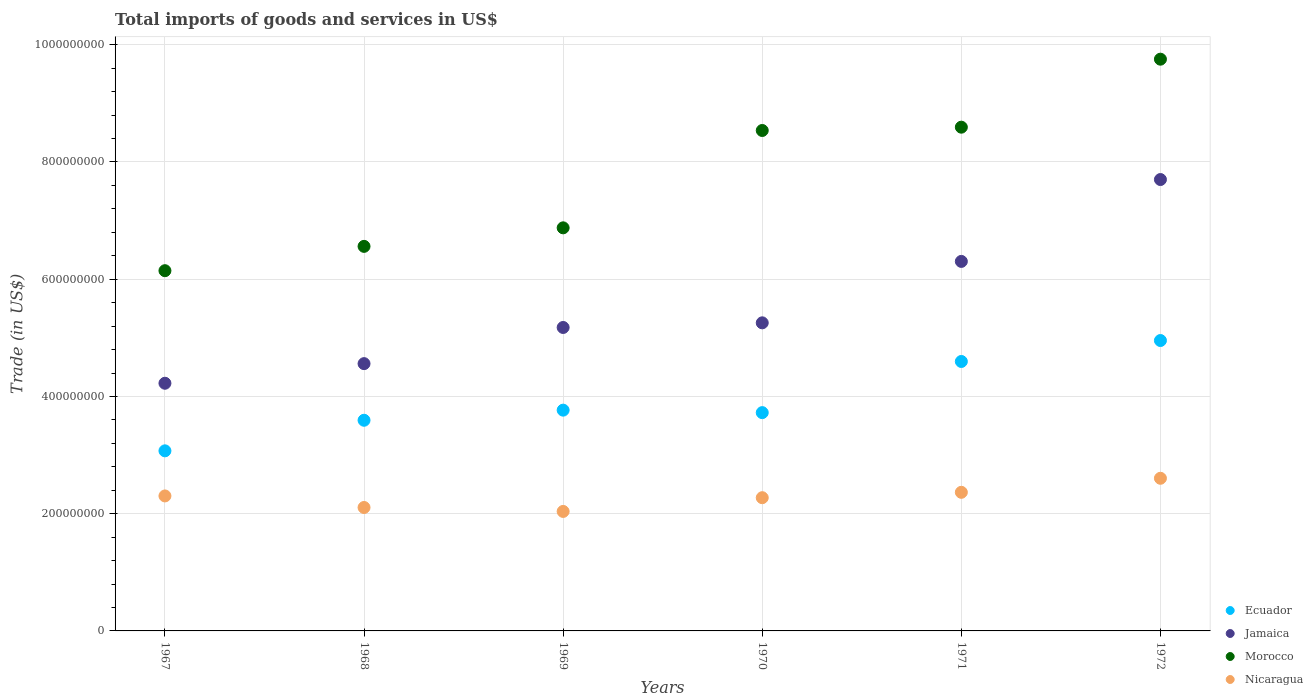What is the total imports of goods and services in Morocco in 1971?
Provide a succinct answer. 8.59e+08. Across all years, what is the maximum total imports of goods and services in Nicaragua?
Provide a short and direct response. 2.60e+08. Across all years, what is the minimum total imports of goods and services in Ecuador?
Offer a very short reply. 3.07e+08. In which year was the total imports of goods and services in Nicaragua minimum?
Your answer should be very brief. 1969. What is the total total imports of goods and services in Ecuador in the graph?
Offer a very short reply. 2.37e+09. What is the difference between the total imports of goods and services in Ecuador in 1969 and that in 1972?
Offer a terse response. -1.19e+08. What is the difference between the total imports of goods and services in Morocco in 1969 and the total imports of goods and services in Jamaica in 1967?
Offer a terse response. 2.65e+08. What is the average total imports of goods and services in Nicaragua per year?
Keep it short and to the point. 2.28e+08. In the year 1968, what is the difference between the total imports of goods and services in Jamaica and total imports of goods and services in Nicaragua?
Keep it short and to the point. 2.45e+08. What is the ratio of the total imports of goods and services in Morocco in 1969 to that in 1972?
Give a very brief answer. 0.71. Is the total imports of goods and services in Morocco in 1968 less than that in 1972?
Give a very brief answer. Yes. What is the difference between the highest and the second highest total imports of goods and services in Morocco?
Keep it short and to the point. 1.16e+08. What is the difference between the highest and the lowest total imports of goods and services in Jamaica?
Provide a succinct answer. 3.48e+08. Is it the case that in every year, the sum of the total imports of goods and services in Ecuador and total imports of goods and services in Jamaica  is greater than the total imports of goods and services in Morocco?
Keep it short and to the point. Yes. Does the total imports of goods and services in Ecuador monotonically increase over the years?
Ensure brevity in your answer.  No. Is the total imports of goods and services in Morocco strictly greater than the total imports of goods and services in Nicaragua over the years?
Ensure brevity in your answer.  Yes. Is the total imports of goods and services in Nicaragua strictly less than the total imports of goods and services in Jamaica over the years?
Offer a very short reply. Yes. How many years are there in the graph?
Offer a terse response. 6. What is the difference between two consecutive major ticks on the Y-axis?
Offer a very short reply. 2.00e+08. Are the values on the major ticks of Y-axis written in scientific E-notation?
Offer a terse response. No. Does the graph contain any zero values?
Your answer should be very brief. No. Does the graph contain grids?
Offer a very short reply. Yes. What is the title of the graph?
Offer a terse response. Total imports of goods and services in US$. Does "Papua New Guinea" appear as one of the legend labels in the graph?
Offer a terse response. No. What is the label or title of the X-axis?
Offer a terse response. Years. What is the label or title of the Y-axis?
Your answer should be very brief. Trade (in US$). What is the Trade (in US$) of Ecuador in 1967?
Offer a very short reply. 3.07e+08. What is the Trade (in US$) of Jamaica in 1967?
Keep it short and to the point. 4.23e+08. What is the Trade (in US$) in Morocco in 1967?
Give a very brief answer. 6.15e+08. What is the Trade (in US$) of Nicaragua in 1967?
Offer a terse response. 2.30e+08. What is the Trade (in US$) of Ecuador in 1968?
Ensure brevity in your answer.  3.59e+08. What is the Trade (in US$) in Jamaica in 1968?
Give a very brief answer. 4.56e+08. What is the Trade (in US$) in Morocco in 1968?
Your response must be concise. 6.56e+08. What is the Trade (in US$) in Nicaragua in 1968?
Make the answer very short. 2.11e+08. What is the Trade (in US$) of Ecuador in 1969?
Your answer should be compact. 3.77e+08. What is the Trade (in US$) in Jamaica in 1969?
Make the answer very short. 5.18e+08. What is the Trade (in US$) of Morocco in 1969?
Your answer should be compact. 6.88e+08. What is the Trade (in US$) of Nicaragua in 1969?
Your answer should be very brief. 2.04e+08. What is the Trade (in US$) in Ecuador in 1970?
Ensure brevity in your answer.  3.72e+08. What is the Trade (in US$) of Jamaica in 1970?
Your answer should be very brief. 5.26e+08. What is the Trade (in US$) in Morocco in 1970?
Ensure brevity in your answer.  8.54e+08. What is the Trade (in US$) in Nicaragua in 1970?
Offer a terse response. 2.27e+08. What is the Trade (in US$) in Ecuador in 1971?
Offer a terse response. 4.60e+08. What is the Trade (in US$) in Jamaica in 1971?
Provide a short and direct response. 6.30e+08. What is the Trade (in US$) of Morocco in 1971?
Your answer should be compact. 8.59e+08. What is the Trade (in US$) in Nicaragua in 1971?
Provide a short and direct response. 2.36e+08. What is the Trade (in US$) in Ecuador in 1972?
Your response must be concise. 4.95e+08. What is the Trade (in US$) of Jamaica in 1972?
Provide a short and direct response. 7.70e+08. What is the Trade (in US$) in Morocco in 1972?
Give a very brief answer. 9.75e+08. What is the Trade (in US$) of Nicaragua in 1972?
Keep it short and to the point. 2.60e+08. Across all years, what is the maximum Trade (in US$) of Ecuador?
Your answer should be compact. 4.95e+08. Across all years, what is the maximum Trade (in US$) of Jamaica?
Your answer should be very brief. 7.70e+08. Across all years, what is the maximum Trade (in US$) of Morocco?
Keep it short and to the point. 9.75e+08. Across all years, what is the maximum Trade (in US$) in Nicaragua?
Offer a terse response. 2.60e+08. Across all years, what is the minimum Trade (in US$) of Ecuador?
Offer a terse response. 3.07e+08. Across all years, what is the minimum Trade (in US$) in Jamaica?
Provide a succinct answer. 4.23e+08. Across all years, what is the minimum Trade (in US$) of Morocco?
Offer a very short reply. 6.15e+08. Across all years, what is the minimum Trade (in US$) of Nicaragua?
Ensure brevity in your answer.  2.04e+08. What is the total Trade (in US$) in Ecuador in the graph?
Offer a terse response. 2.37e+09. What is the total Trade (in US$) in Jamaica in the graph?
Your answer should be very brief. 3.32e+09. What is the total Trade (in US$) in Morocco in the graph?
Your answer should be very brief. 4.65e+09. What is the total Trade (in US$) in Nicaragua in the graph?
Your answer should be compact. 1.37e+09. What is the difference between the Trade (in US$) in Ecuador in 1967 and that in 1968?
Ensure brevity in your answer.  -5.22e+07. What is the difference between the Trade (in US$) in Jamaica in 1967 and that in 1968?
Your answer should be very brief. -3.35e+07. What is the difference between the Trade (in US$) of Morocco in 1967 and that in 1968?
Your response must be concise. -4.15e+07. What is the difference between the Trade (in US$) of Nicaragua in 1967 and that in 1968?
Offer a terse response. 1.97e+07. What is the difference between the Trade (in US$) of Ecuador in 1967 and that in 1969?
Your response must be concise. -6.94e+07. What is the difference between the Trade (in US$) of Jamaica in 1967 and that in 1969?
Offer a terse response. -9.51e+07. What is the difference between the Trade (in US$) of Morocco in 1967 and that in 1969?
Provide a short and direct response. -7.31e+07. What is the difference between the Trade (in US$) of Nicaragua in 1967 and that in 1969?
Your response must be concise. 2.64e+07. What is the difference between the Trade (in US$) in Ecuador in 1967 and that in 1970?
Your answer should be very brief. -6.52e+07. What is the difference between the Trade (in US$) of Jamaica in 1967 and that in 1970?
Offer a terse response. -1.03e+08. What is the difference between the Trade (in US$) in Morocco in 1967 and that in 1970?
Your response must be concise. -2.39e+08. What is the difference between the Trade (in US$) in Nicaragua in 1967 and that in 1970?
Provide a succinct answer. 3.01e+06. What is the difference between the Trade (in US$) in Ecuador in 1967 and that in 1971?
Provide a short and direct response. -1.52e+08. What is the difference between the Trade (in US$) of Jamaica in 1967 and that in 1971?
Keep it short and to the point. -2.08e+08. What is the difference between the Trade (in US$) of Morocco in 1967 and that in 1971?
Ensure brevity in your answer.  -2.45e+08. What is the difference between the Trade (in US$) in Nicaragua in 1967 and that in 1971?
Your answer should be compact. -6.18e+06. What is the difference between the Trade (in US$) of Ecuador in 1967 and that in 1972?
Your answer should be compact. -1.88e+08. What is the difference between the Trade (in US$) of Jamaica in 1967 and that in 1972?
Provide a succinct answer. -3.48e+08. What is the difference between the Trade (in US$) of Morocco in 1967 and that in 1972?
Your response must be concise. -3.61e+08. What is the difference between the Trade (in US$) of Nicaragua in 1967 and that in 1972?
Your response must be concise. -3.01e+07. What is the difference between the Trade (in US$) of Ecuador in 1968 and that in 1969?
Offer a very short reply. -1.73e+07. What is the difference between the Trade (in US$) in Jamaica in 1968 and that in 1969?
Your answer should be compact. -6.17e+07. What is the difference between the Trade (in US$) of Morocco in 1968 and that in 1969?
Offer a very short reply. -3.16e+07. What is the difference between the Trade (in US$) of Nicaragua in 1968 and that in 1969?
Ensure brevity in your answer.  6.72e+06. What is the difference between the Trade (in US$) in Ecuador in 1968 and that in 1970?
Give a very brief answer. -1.30e+07. What is the difference between the Trade (in US$) in Jamaica in 1968 and that in 1970?
Provide a succinct answer. -6.96e+07. What is the difference between the Trade (in US$) in Morocco in 1968 and that in 1970?
Your answer should be compact. -1.98e+08. What is the difference between the Trade (in US$) in Nicaragua in 1968 and that in 1970?
Give a very brief answer. -1.67e+07. What is the difference between the Trade (in US$) of Ecuador in 1968 and that in 1971?
Your response must be concise. -1.00e+08. What is the difference between the Trade (in US$) in Jamaica in 1968 and that in 1971?
Keep it short and to the point. -1.74e+08. What is the difference between the Trade (in US$) of Morocco in 1968 and that in 1971?
Keep it short and to the point. -2.03e+08. What is the difference between the Trade (in US$) of Nicaragua in 1968 and that in 1971?
Your answer should be compact. -2.59e+07. What is the difference between the Trade (in US$) of Ecuador in 1968 and that in 1972?
Your answer should be compact. -1.36e+08. What is the difference between the Trade (in US$) of Jamaica in 1968 and that in 1972?
Your response must be concise. -3.14e+08. What is the difference between the Trade (in US$) in Morocco in 1968 and that in 1972?
Provide a succinct answer. -3.19e+08. What is the difference between the Trade (in US$) in Nicaragua in 1968 and that in 1972?
Your answer should be compact. -4.99e+07. What is the difference between the Trade (in US$) in Ecuador in 1969 and that in 1970?
Your answer should be compact. 4.23e+06. What is the difference between the Trade (in US$) of Jamaica in 1969 and that in 1970?
Offer a terse response. -7.92e+06. What is the difference between the Trade (in US$) of Morocco in 1969 and that in 1970?
Your answer should be very brief. -1.66e+08. What is the difference between the Trade (in US$) in Nicaragua in 1969 and that in 1970?
Your answer should be compact. -2.34e+07. What is the difference between the Trade (in US$) in Ecuador in 1969 and that in 1971?
Provide a short and direct response. -8.30e+07. What is the difference between the Trade (in US$) in Jamaica in 1969 and that in 1971?
Give a very brief answer. -1.13e+08. What is the difference between the Trade (in US$) of Morocco in 1969 and that in 1971?
Offer a very short reply. -1.72e+08. What is the difference between the Trade (in US$) in Nicaragua in 1969 and that in 1971?
Give a very brief answer. -3.26e+07. What is the difference between the Trade (in US$) of Ecuador in 1969 and that in 1972?
Provide a succinct answer. -1.19e+08. What is the difference between the Trade (in US$) of Jamaica in 1969 and that in 1972?
Your answer should be very brief. -2.52e+08. What is the difference between the Trade (in US$) in Morocco in 1969 and that in 1972?
Your response must be concise. -2.88e+08. What is the difference between the Trade (in US$) of Nicaragua in 1969 and that in 1972?
Provide a short and direct response. -5.66e+07. What is the difference between the Trade (in US$) of Ecuador in 1970 and that in 1971?
Ensure brevity in your answer.  -8.73e+07. What is the difference between the Trade (in US$) in Jamaica in 1970 and that in 1971?
Your answer should be compact. -1.05e+08. What is the difference between the Trade (in US$) in Morocco in 1970 and that in 1971?
Offer a terse response. -5.64e+06. What is the difference between the Trade (in US$) in Nicaragua in 1970 and that in 1971?
Provide a succinct answer. -9.19e+06. What is the difference between the Trade (in US$) of Ecuador in 1970 and that in 1972?
Your response must be concise. -1.23e+08. What is the difference between the Trade (in US$) of Jamaica in 1970 and that in 1972?
Provide a short and direct response. -2.44e+08. What is the difference between the Trade (in US$) of Morocco in 1970 and that in 1972?
Your answer should be compact. -1.22e+08. What is the difference between the Trade (in US$) in Nicaragua in 1970 and that in 1972?
Provide a short and direct response. -3.31e+07. What is the difference between the Trade (in US$) in Ecuador in 1971 and that in 1972?
Your answer should be very brief. -3.57e+07. What is the difference between the Trade (in US$) in Jamaica in 1971 and that in 1972?
Offer a terse response. -1.40e+08. What is the difference between the Trade (in US$) of Morocco in 1971 and that in 1972?
Your response must be concise. -1.16e+08. What is the difference between the Trade (in US$) of Nicaragua in 1971 and that in 1972?
Offer a very short reply. -2.40e+07. What is the difference between the Trade (in US$) of Ecuador in 1967 and the Trade (in US$) of Jamaica in 1968?
Give a very brief answer. -1.49e+08. What is the difference between the Trade (in US$) in Ecuador in 1967 and the Trade (in US$) in Morocco in 1968?
Provide a succinct answer. -3.49e+08. What is the difference between the Trade (in US$) of Ecuador in 1967 and the Trade (in US$) of Nicaragua in 1968?
Provide a short and direct response. 9.67e+07. What is the difference between the Trade (in US$) of Jamaica in 1967 and the Trade (in US$) of Morocco in 1968?
Make the answer very short. -2.34e+08. What is the difference between the Trade (in US$) in Jamaica in 1967 and the Trade (in US$) in Nicaragua in 1968?
Your response must be concise. 2.12e+08. What is the difference between the Trade (in US$) of Morocco in 1967 and the Trade (in US$) of Nicaragua in 1968?
Give a very brief answer. 4.04e+08. What is the difference between the Trade (in US$) of Ecuador in 1967 and the Trade (in US$) of Jamaica in 1969?
Give a very brief answer. -2.10e+08. What is the difference between the Trade (in US$) in Ecuador in 1967 and the Trade (in US$) in Morocco in 1969?
Offer a very short reply. -3.80e+08. What is the difference between the Trade (in US$) in Ecuador in 1967 and the Trade (in US$) in Nicaragua in 1969?
Ensure brevity in your answer.  1.03e+08. What is the difference between the Trade (in US$) of Jamaica in 1967 and the Trade (in US$) of Morocco in 1969?
Offer a very short reply. -2.65e+08. What is the difference between the Trade (in US$) in Jamaica in 1967 and the Trade (in US$) in Nicaragua in 1969?
Provide a succinct answer. 2.19e+08. What is the difference between the Trade (in US$) of Morocco in 1967 and the Trade (in US$) of Nicaragua in 1969?
Provide a short and direct response. 4.11e+08. What is the difference between the Trade (in US$) in Ecuador in 1967 and the Trade (in US$) in Jamaica in 1970?
Make the answer very short. -2.18e+08. What is the difference between the Trade (in US$) of Ecuador in 1967 and the Trade (in US$) of Morocco in 1970?
Give a very brief answer. -5.47e+08. What is the difference between the Trade (in US$) in Ecuador in 1967 and the Trade (in US$) in Nicaragua in 1970?
Your answer should be very brief. 8.00e+07. What is the difference between the Trade (in US$) of Jamaica in 1967 and the Trade (in US$) of Morocco in 1970?
Keep it short and to the point. -4.31e+08. What is the difference between the Trade (in US$) of Jamaica in 1967 and the Trade (in US$) of Nicaragua in 1970?
Make the answer very short. 1.95e+08. What is the difference between the Trade (in US$) of Morocco in 1967 and the Trade (in US$) of Nicaragua in 1970?
Provide a short and direct response. 3.87e+08. What is the difference between the Trade (in US$) in Ecuador in 1967 and the Trade (in US$) in Jamaica in 1971?
Provide a succinct answer. -3.23e+08. What is the difference between the Trade (in US$) in Ecuador in 1967 and the Trade (in US$) in Morocco in 1971?
Your answer should be compact. -5.52e+08. What is the difference between the Trade (in US$) of Ecuador in 1967 and the Trade (in US$) of Nicaragua in 1971?
Your answer should be very brief. 7.08e+07. What is the difference between the Trade (in US$) in Jamaica in 1967 and the Trade (in US$) in Morocco in 1971?
Provide a succinct answer. -4.37e+08. What is the difference between the Trade (in US$) of Jamaica in 1967 and the Trade (in US$) of Nicaragua in 1971?
Your answer should be very brief. 1.86e+08. What is the difference between the Trade (in US$) in Morocco in 1967 and the Trade (in US$) in Nicaragua in 1971?
Ensure brevity in your answer.  3.78e+08. What is the difference between the Trade (in US$) of Ecuador in 1967 and the Trade (in US$) of Jamaica in 1972?
Make the answer very short. -4.63e+08. What is the difference between the Trade (in US$) of Ecuador in 1967 and the Trade (in US$) of Morocco in 1972?
Offer a terse response. -6.68e+08. What is the difference between the Trade (in US$) of Ecuador in 1967 and the Trade (in US$) of Nicaragua in 1972?
Ensure brevity in your answer.  4.68e+07. What is the difference between the Trade (in US$) in Jamaica in 1967 and the Trade (in US$) in Morocco in 1972?
Keep it short and to the point. -5.53e+08. What is the difference between the Trade (in US$) of Jamaica in 1967 and the Trade (in US$) of Nicaragua in 1972?
Your response must be concise. 1.62e+08. What is the difference between the Trade (in US$) of Morocco in 1967 and the Trade (in US$) of Nicaragua in 1972?
Give a very brief answer. 3.54e+08. What is the difference between the Trade (in US$) in Ecuador in 1968 and the Trade (in US$) in Jamaica in 1969?
Provide a succinct answer. -1.58e+08. What is the difference between the Trade (in US$) in Ecuador in 1968 and the Trade (in US$) in Morocco in 1969?
Offer a terse response. -3.28e+08. What is the difference between the Trade (in US$) of Ecuador in 1968 and the Trade (in US$) of Nicaragua in 1969?
Your answer should be compact. 1.56e+08. What is the difference between the Trade (in US$) in Jamaica in 1968 and the Trade (in US$) in Morocco in 1969?
Your response must be concise. -2.32e+08. What is the difference between the Trade (in US$) in Jamaica in 1968 and the Trade (in US$) in Nicaragua in 1969?
Your answer should be very brief. 2.52e+08. What is the difference between the Trade (in US$) in Morocco in 1968 and the Trade (in US$) in Nicaragua in 1969?
Keep it short and to the point. 4.52e+08. What is the difference between the Trade (in US$) of Ecuador in 1968 and the Trade (in US$) of Jamaica in 1970?
Give a very brief answer. -1.66e+08. What is the difference between the Trade (in US$) of Ecuador in 1968 and the Trade (in US$) of Morocco in 1970?
Your response must be concise. -4.94e+08. What is the difference between the Trade (in US$) of Ecuador in 1968 and the Trade (in US$) of Nicaragua in 1970?
Give a very brief answer. 1.32e+08. What is the difference between the Trade (in US$) in Jamaica in 1968 and the Trade (in US$) in Morocco in 1970?
Provide a succinct answer. -3.98e+08. What is the difference between the Trade (in US$) in Jamaica in 1968 and the Trade (in US$) in Nicaragua in 1970?
Your response must be concise. 2.29e+08. What is the difference between the Trade (in US$) of Morocco in 1968 and the Trade (in US$) of Nicaragua in 1970?
Ensure brevity in your answer.  4.29e+08. What is the difference between the Trade (in US$) of Ecuador in 1968 and the Trade (in US$) of Jamaica in 1971?
Provide a succinct answer. -2.71e+08. What is the difference between the Trade (in US$) in Ecuador in 1968 and the Trade (in US$) in Morocco in 1971?
Provide a short and direct response. -5.00e+08. What is the difference between the Trade (in US$) in Ecuador in 1968 and the Trade (in US$) in Nicaragua in 1971?
Offer a terse response. 1.23e+08. What is the difference between the Trade (in US$) in Jamaica in 1968 and the Trade (in US$) in Morocco in 1971?
Ensure brevity in your answer.  -4.03e+08. What is the difference between the Trade (in US$) in Jamaica in 1968 and the Trade (in US$) in Nicaragua in 1971?
Give a very brief answer. 2.20e+08. What is the difference between the Trade (in US$) in Morocco in 1968 and the Trade (in US$) in Nicaragua in 1971?
Your answer should be very brief. 4.20e+08. What is the difference between the Trade (in US$) of Ecuador in 1968 and the Trade (in US$) of Jamaica in 1972?
Your answer should be compact. -4.11e+08. What is the difference between the Trade (in US$) of Ecuador in 1968 and the Trade (in US$) of Morocco in 1972?
Give a very brief answer. -6.16e+08. What is the difference between the Trade (in US$) of Ecuador in 1968 and the Trade (in US$) of Nicaragua in 1972?
Make the answer very short. 9.90e+07. What is the difference between the Trade (in US$) of Jamaica in 1968 and the Trade (in US$) of Morocco in 1972?
Make the answer very short. -5.19e+08. What is the difference between the Trade (in US$) in Jamaica in 1968 and the Trade (in US$) in Nicaragua in 1972?
Offer a very short reply. 1.96e+08. What is the difference between the Trade (in US$) in Morocco in 1968 and the Trade (in US$) in Nicaragua in 1972?
Ensure brevity in your answer.  3.96e+08. What is the difference between the Trade (in US$) in Ecuador in 1969 and the Trade (in US$) in Jamaica in 1970?
Ensure brevity in your answer.  -1.49e+08. What is the difference between the Trade (in US$) in Ecuador in 1969 and the Trade (in US$) in Morocco in 1970?
Provide a succinct answer. -4.77e+08. What is the difference between the Trade (in US$) in Ecuador in 1969 and the Trade (in US$) in Nicaragua in 1970?
Keep it short and to the point. 1.49e+08. What is the difference between the Trade (in US$) in Jamaica in 1969 and the Trade (in US$) in Morocco in 1970?
Offer a very short reply. -3.36e+08. What is the difference between the Trade (in US$) of Jamaica in 1969 and the Trade (in US$) of Nicaragua in 1970?
Offer a terse response. 2.90e+08. What is the difference between the Trade (in US$) in Morocco in 1969 and the Trade (in US$) in Nicaragua in 1970?
Keep it short and to the point. 4.60e+08. What is the difference between the Trade (in US$) of Ecuador in 1969 and the Trade (in US$) of Jamaica in 1971?
Your answer should be very brief. -2.54e+08. What is the difference between the Trade (in US$) of Ecuador in 1969 and the Trade (in US$) of Morocco in 1971?
Give a very brief answer. -4.83e+08. What is the difference between the Trade (in US$) of Ecuador in 1969 and the Trade (in US$) of Nicaragua in 1971?
Give a very brief answer. 1.40e+08. What is the difference between the Trade (in US$) in Jamaica in 1969 and the Trade (in US$) in Morocco in 1971?
Your answer should be compact. -3.42e+08. What is the difference between the Trade (in US$) in Jamaica in 1969 and the Trade (in US$) in Nicaragua in 1971?
Make the answer very short. 2.81e+08. What is the difference between the Trade (in US$) of Morocco in 1969 and the Trade (in US$) of Nicaragua in 1971?
Your answer should be very brief. 4.51e+08. What is the difference between the Trade (in US$) in Ecuador in 1969 and the Trade (in US$) in Jamaica in 1972?
Provide a succinct answer. -3.93e+08. What is the difference between the Trade (in US$) in Ecuador in 1969 and the Trade (in US$) in Morocco in 1972?
Offer a very short reply. -5.99e+08. What is the difference between the Trade (in US$) in Ecuador in 1969 and the Trade (in US$) in Nicaragua in 1972?
Offer a very short reply. 1.16e+08. What is the difference between the Trade (in US$) in Jamaica in 1969 and the Trade (in US$) in Morocco in 1972?
Ensure brevity in your answer.  -4.58e+08. What is the difference between the Trade (in US$) in Jamaica in 1969 and the Trade (in US$) in Nicaragua in 1972?
Offer a terse response. 2.57e+08. What is the difference between the Trade (in US$) of Morocco in 1969 and the Trade (in US$) of Nicaragua in 1972?
Your answer should be very brief. 4.27e+08. What is the difference between the Trade (in US$) of Ecuador in 1970 and the Trade (in US$) of Jamaica in 1971?
Your answer should be very brief. -2.58e+08. What is the difference between the Trade (in US$) of Ecuador in 1970 and the Trade (in US$) of Morocco in 1971?
Ensure brevity in your answer.  -4.87e+08. What is the difference between the Trade (in US$) of Ecuador in 1970 and the Trade (in US$) of Nicaragua in 1971?
Offer a terse response. 1.36e+08. What is the difference between the Trade (in US$) in Jamaica in 1970 and the Trade (in US$) in Morocco in 1971?
Ensure brevity in your answer.  -3.34e+08. What is the difference between the Trade (in US$) in Jamaica in 1970 and the Trade (in US$) in Nicaragua in 1971?
Keep it short and to the point. 2.89e+08. What is the difference between the Trade (in US$) of Morocco in 1970 and the Trade (in US$) of Nicaragua in 1971?
Offer a terse response. 6.17e+08. What is the difference between the Trade (in US$) in Ecuador in 1970 and the Trade (in US$) in Jamaica in 1972?
Keep it short and to the point. -3.98e+08. What is the difference between the Trade (in US$) in Ecuador in 1970 and the Trade (in US$) in Morocco in 1972?
Your answer should be very brief. -6.03e+08. What is the difference between the Trade (in US$) of Ecuador in 1970 and the Trade (in US$) of Nicaragua in 1972?
Provide a short and direct response. 1.12e+08. What is the difference between the Trade (in US$) of Jamaica in 1970 and the Trade (in US$) of Morocco in 1972?
Keep it short and to the point. -4.50e+08. What is the difference between the Trade (in US$) in Jamaica in 1970 and the Trade (in US$) in Nicaragua in 1972?
Offer a terse response. 2.65e+08. What is the difference between the Trade (in US$) of Morocco in 1970 and the Trade (in US$) of Nicaragua in 1972?
Keep it short and to the point. 5.93e+08. What is the difference between the Trade (in US$) in Ecuador in 1971 and the Trade (in US$) in Jamaica in 1972?
Provide a short and direct response. -3.10e+08. What is the difference between the Trade (in US$) in Ecuador in 1971 and the Trade (in US$) in Morocco in 1972?
Provide a succinct answer. -5.16e+08. What is the difference between the Trade (in US$) of Ecuador in 1971 and the Trade (in US$) of Nicaragua in 1972?
Provide a succinct answer. 1.99e+08. What is the difference between the Trade (in US$) of Jamaica in 1971 and the Trade (in US$) of Morocco in 1972?
Your response must be concise. -3.45e+08. What is the difference between the Trade (in US$) in Jamaica in 1971 and the Trade (in US$) in Nicaragua in 1972?
Give a very brief answer. 3.70e+08. What is the difference between the Trade (in US$) of Morocco in 1971 and the Trade (in US$) of Nicaragua in 1972?
Your answer should be compact. 5.99e+08. What is the average Trade (in US$) of Ecuador per year?
Provide a short and direct response. 3.95e+08. What is the average Trade (in US$) of Jamaica per year?
Offer a terse response. 5.54e+08. What is the average Trade (in US$) in Morocco per year?
Provide a succinct answer. 7.74e+08. What is the average Trade (in US$) of Nicaragua per year?
Make the answer very short. 2.28e+08. In the year 1967, what is the difference between the Trade (in US$) in Ecuador and Trade (in US$) in Jamaica?
Provide a succinct answer. -1.15e+08. In the year 1967, what is the difference between the Trade (in US$) in Ecuador and Trade (in US$) in Morocco?
Give a very brief answer. -3.07e+08. In the year 1967, what is the difference between the Trade (in US$) of Ecuador and Trade (in US$) of Nicaragua?
Provide a succinct answer. 7.69e+07. In the year 1967, what is the difference between the Trade (in US$) in Jamaica and Trade (in US$) in Morocco?
Offer a terse response. -1.92e+08. In the year 1967, what is the difference between the Trade (in US$) in Jamaica and Trade (in US$) in Nicaragua?
Your response must be concise. 1.92e+08. In the year 1967, what is the difference between the Trade (in US$) of Morocco and Trade (in US$) of Nicaragua?
Offer a terse response. 3.84e+08. In the year 1968, what is the difference between the Trade (in US$) in Ecuador and Trade (in US$) in Jamaica?
Offer a very short reply. -9.66e+07. In the year 1968, what is the difference between the Trade (in US$) in Ecuador and Trade (in US$) in Morocco?
Your answer should be very brief. -2.97e+08. In the year 1968, what is the difference between the Trade (in US$) of Ecuador and Trade (in US$) of Nicaragua?
Give a very brief answer. 1.49e+08. In the year 1968, what is the difference between the Trade (in US$) in Jamaica and Trade (in US$) in Morocco?
Your answer should be compact. -2.00e+08. In the year 1968, what is the difference between the Trade (in US$) in Jamaica and Trade (in US$) in Nicaragua?
Provide a short and direct response. 2.45e+08. In the year 1968, what is the difference between the Trade (in US$) in Morocco and Trade (in US$) in Nicaragua?
Give a very brief answer. 4.45e+08. In the year 1969, what is the difference between the Trade (in US$) in Ecuador and Trade (in US$) in Jamaica?
Your answer should be compact. -1.41e+08. In the year 1969, what is the difference between the Trade (in US$) of Ecuador and Trade (in US$) of Morocco?
Your answer should be compact. -3.11e+08. In the year 1969, what is the difference between the Trade (in US$) of Ecuador and Trade (in US$) of Nicaragua?
Offer a very short reply. 1.73e+08. In the year 1969, what is the difference between the Trade (in US$) in Jamaica and Trade (in US$) in Morocco?
Make the answer very short. -1.70e+08. In the year 1969, what is the difference between the Trade (in US$) in Jamaica and Trade (in US$) in Nicaragua?
Make the answer very short. 3.14e+08. In the year 1969, what is the difference between the Trade (in US$) in Morocco and Trade (in US$) in Nicaragua?
Ensure brevity in your answer.  4.84e+08. In the year 1970, what is the difference between the Trade (in US$) in Ecuador and Trade (in US$) in Jamaica?
Your answer should be compact. -1.53e+08. In the year 1970, what is the difference between the Trade (in US$) in Ecuador and Trade (in US$) in Morocco?
Make the answer very short. -4.81e+08. In the year 1970, what is the difference between the Trade (in US$) of Ecuador and Trade (in US$) of Nicaragua?
Your response must be concise. 1.45e+08. In the year 1970, what is the difference between the Trade (in US$) in Jamaica and Trade (in US$) in Morocco?
Make the answer very short. -3.28e+08. In the year 1970, what is the difference between the Trade (in US$) in Jamaica and Trade (in US$) in Nicaragua?
Offer a very short reply. 2.98e+08. In the year 1970, what is the difference between the Trade (in US$) of Morocco and Trade (in US$) of Nicaragua?
Give a very brief answer. 6.26e+08. In the year 1971, what is the difference between the Trade (in US$) of Ecuador and Trade (in US$) of Jamaica?
Your response must be concise. -1.71e+08. In the year 1971, what is the difference between the Trade (in US$) in Ecuador and Trade (in US$) in Morocco?
Your response must be concise. -4.00e+08. In the year 1971, what is the difference between the Trade (in US$) of Ecuador and Trade (in US$) of Nicaragua?
Give a very brief answer. 2.23e+08. In the year 1971, what is the difference between the Trade (in US$) in Jamaica and Trade (in US$) in Morocco?
Keep it short and to the point. -2.29e+08. In the year 1971, what is the difference between the Trade (in US$) in Jamaica and Trade (in US$) in Nicaragua?
Provide a short and direct response. 3.94e+08. In the year 1971, what is the difference between the Trade (in US$) in Morocco and Trade (in US$) in Nicaragua?
Provide a short and direct response. 6.23e+08. In the year 1972, what is the difference between the Trade (in US$) of Ecuador and Trade (in US$) of Jamaica?
Your response must be concise. -2.75e+08. In the year 1972, what is the difference between the Trade (in US$) of Ecuador and Trade (in US$) of Morocco?
Your answer should be compact. -4.80e+08. In the year 1972, what is the difference between the Trade (in US$) of Ecuador and Trade (in US$) of Nicaragua?
Offer a very short reply. 2.35e+08. In the year 1972, what is the difference between the Trade (in US$) of Jamaica and Trade (in US$) of Morocco?
Keep it short and to the point. -2.05e+08. In the year 1972, what is the difference between the Trade (in US$) of Jamaica and Trade (in US$) of Nicaragua?
Your answer should be very brief. 5.10e+08. In the year 1972, what is the difference between the Trade (in US$) in Morocco and Trade (in US$) in Nicaragua?
Your response must be concise. 7.15e+08. What is the ratio of the Trade (in US$) of Ecuador in 1967 to that in 1968?
Keep it short and to the point. 0.85. What is the ratio of the Trade (in US$) in Jamaica in 1967 to that in 1968?
Provide a short and direct response. 0.93. What is the ratio of the Trade (in US$) of Morocco in 1967 to that in 1968?
Your response must be concise. 0.94. What is the ratio of the Trade (in US$) of Nicaragua in 1967 to that in 1968?
Your answer should be compact. 1.09. What is the ratio of the Trade (in US$) in Ecuador in 1967 to that in 1969?
Offer a terse response. 0.82. What is the ratio of the Trade (in US$) of Jamaica in 1967 to that in 1969?
Offer a very short reply. 0.82. What is the ratio of the Trade (in US$) of Morocco in 1967 to that in 1969?
Your response must be concise. 0.89. What is the ratio of the Trade (in US$) in Nicaragua in 1967 to that in 1969?
Your response must be concise. 1.13. What is the ratio of the Trade (in US$) of Ecuador in 1967 to that in 1970?
Your answer should be very brief. 0.82. What is the ratio of the Trade (in US$) in Jamaica in 1967 to that in 1970?
Give a very brief answer. 0.8. What is the ratio of the Trade (in US$) of Morocco in 1967 to that in 1970?
Keep it short and to the point. 0.72. What is the ratio of the Trade (in US$) of Nicaragua in 1967 to that in 1970?
Keep it short and to the point. 1.01. What is the ratio of the Trade (in US$) in Ecuador in 1967 to that in 1971?
Your answer should be very brief. 0.67. What is the ratio of the Trade (in US$) of Jamaica in 1967 to that in 1971?
Provide a short and direct response. 0.67. What is the ratio of the Trade (in US$) in Morocco in 1967 to that in 1971?
Your response must be concise. 0.72. What is the ratio of the Trade (in US$) in Nicaragua in 1967 to that in 1971?
Your answer should be compact. 0.97. What is the ratio of the Trade (in US$) in Ecuador in 1967 to that in 1972?
Your response must be concise. 0.62. What is the ratio of the Trade (in US$) of Jamaica in 1967 to that in 1972?
Your response must be concise. 0.55. What is the ratio of the Trade (in US$) of Morocco in 1967 to that in 1972?
Give a very brief answer. 0.63. What is the ratio of the Trade (in US$) in Nicaragua in 1967 to that in 1972?
Your response must be concise. 0.88. What is the ratio of the Trade (in US$) of Ecuador in 1968 to that in 1969?
Keep it short and to the point. 0.95. What is the ratio of the Trade (in US$) in Jamaica in 1968 to that in 1969?
Provide a succinct answer. 0.88. What is the ratio of the Trade (in US$) of Morocco in 1968 to that in 1969?
Your response must be concise. 0.95. What is the ratio of the Trade (in US$) in Nicaragua in 1968 to that in 1969?
Keep it short and to the point. 1.03. What is the ratio of the Trade (in US$) of Ecuador in 1968 to that in 1970?
Keep it short and to the point. 0.96. What is the ratio of the Trade (in US$) of Jamaica in 1968 to that in 1970?
Provide a succinct answer. 0.87. What is the ratio of the Trade (in US$) in Morocco in 1968 to that in 1970?
Keep it short and to the point. 0.77. What is the ratio of the Trade (in US$) in Nicaragua in 1968 to that in 1970?
Keep it short and to the point. 0.93. What is the ratio of the Trade (in US$) of Ecuador in 1968 to that in 1971?
Keep it short and to the point. 0.78. What is the ratio of the Trade (in US$) of Jamaica in 1968 to that in 1971?
Give a very brief answer. 0.72. What is the ratio of the Trade (in US$) in Morocco in 1968 to that in 1971?
Offer a very short reply. 0.76. What is the ratio of the Trade (in US$) of Nicaragua in 1968 to that in 1971?
Your answer should be very brief. 0.89. What is the ratio of the Trade (in US$) in Ecuador in 1968 to that in 1972?
Make the answer very short. 0.73. What is the ratio of the Trade (in US$) in Jamaica in 1968 to that in 1972?
Give a very brief answer. 0.59. What is the ratio of the Trade (in US$) of Morocco in 1968 to that in 1972?
Your response must be concise. 0.67. What is the ratio of the Trade (in US$) of Nicaragua in 1968 to that in 1972?
Ensure brevity in your answer.  0.81. What is the ratio of the Trade (in US$) of Ecuador in 1969 to that in 1970?
Provide a succinct answer. 1.01. What is the ratio of the Trade (in US$) of Jamaica in 1969 to that in 1970?
Provide a succinct answer. 0.98. What is the ratio of the Trade (in US$) of Morocco in 1969 to that in 1970?
Provide a succinct answer. 0.81. What is the ratio of the Trade (in US$) of Nicaragua in 1969 to that in 1970?
Your response must be concise. 0.9. What is the ratio of the Trade (in US$) of Ecuador in 1969 to that in 1971?
Provide a succinct answer. 0.82. What is the ratio of the Trade (in US$) in Jamaica in 1969 to that in 1971?
Give a very brief answer. 0.82. What is the ratio of the Trade (in US$) of Morocco in 1969 to that in 1971?
Provide a succinct answer. 0.8. What is the ratio of the Trade (in US$) in Nicaragua in 1969 to that in 1971?
Ensure brevity in your answer.  0.86. What is the ratio of the Trade (in US$) of Ecuador in 1969 to that in 1972?
Your answer should be compact. 0.76. What is the ratio of the Trade (in US$) of Jamaica in 1969 to that in 1972?
Your answer should be compact. 0.67. What is the ratio of the Trade (in US$) in Morocco in 1969 to that in 1972?
Provide a succinct answer. 0.7. What is the ratio of the Trade (in US$) of Nicaragua in 1969 to that in 1972?
Keep it short and to the point. 0.78. What is the ratio of the Trade (in US$) of Ecuador in 1970 to that in 1971?
Offer a very short reply. 0.81. What is the ratio of the Trade (in US$) of Jamaica in 1970 to that in 1971?
Offer a very short reply. 0.83. What is the ratio of the Trade (in US$) in Morocco in 1970 to that in 1971?
Give a very brief answer. 0.99. What is the ratio of the Trade (in US$) in Nicaragua in 1970 to that in 1971?
Provide a succinct answer. 0.96. What is the ratio of the Trade (in US$) in Ecuador in 1970 to that in 1972?
Keep it short and to the point. 0.75. What is the ratio of the Trade (in US$) of Jamaica in 1970 to that in 1972?
Provide a succinct answer. 0.68. What is the ratio of the Trade (in US$) of Morocco in 1970 to that in 1972?
Provide a short and direct response. 0.88. What is the ratio of the Trade (in US$) in Nicaragua in 1970 to that in 1972?
Offer a terse response. 0.87. What is the ratio of the Trade (in US$) in Ecuador in 1971 to that in 1972?
Give a very brief answer. 0.93. What is the ratio of the Trade (in US$) in Jamaica in 1971 to that in 1972?
Give a very brief answer. 0.82. What is the ratio of the Trade (in US$) in Morocco in 1971 to that in 1972?
Your answer should be very brief. 0.88. What is the ratio of the Trade (in US$) in Nicaragua in 1971 to that in 1972?
Keep it short and to the point. 0.91. What is the difference between the highest and the second highest Trade (in US$) of Ecuador?
Keep it short and to the point. 3.57e+07. What is the difference between the highest and the second highest Trade (in US$) of Jamaica?
Your answer should be compact. 1.40e+08. What is the difference between the highest and the second highest Trade (in US$) in Morocco?
Your answer should be compact. 1.16e+08. What is the difference between the highest and the second highest Trade (in US$) in Nicaragua?
Make the answer very short. 2.40e+07. What is the difference between the highest and the lowest Trade (in US$) in Ecuador?
Offer a very short reply. 1.88e+08. What is the difference between the highest and the lowest Trade (in US$) in Jamaica?
Keep it short and to the point. 3.48e+08. What is the difference between the highest and the lowest Trade (in US$) in Morocco?
Offer a very short reply. 3.61e+08. What is the difference between the highest and the lowest Trade (in US$) of Nicaragua?
Make the answer very short. 5.66e+07. 